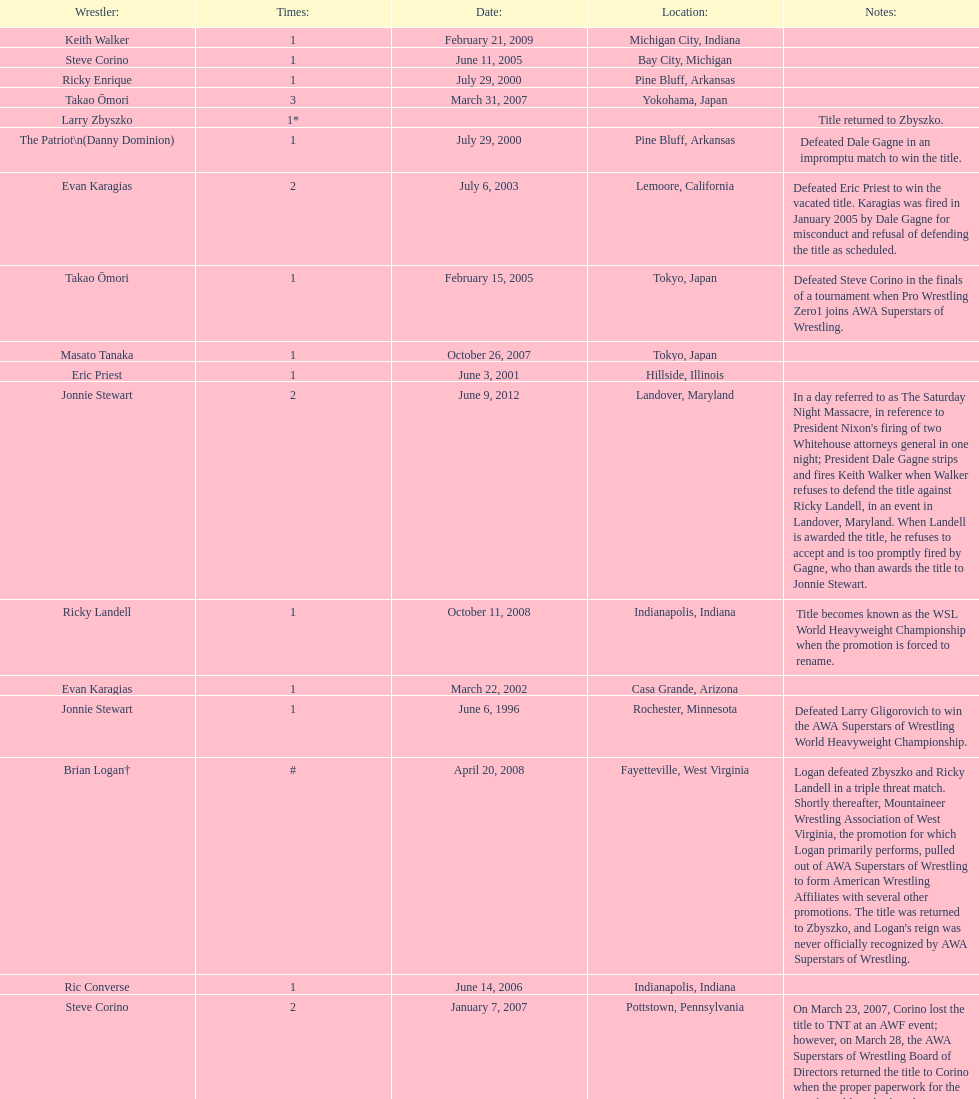What are the number of matches that happened in japan? 5. 